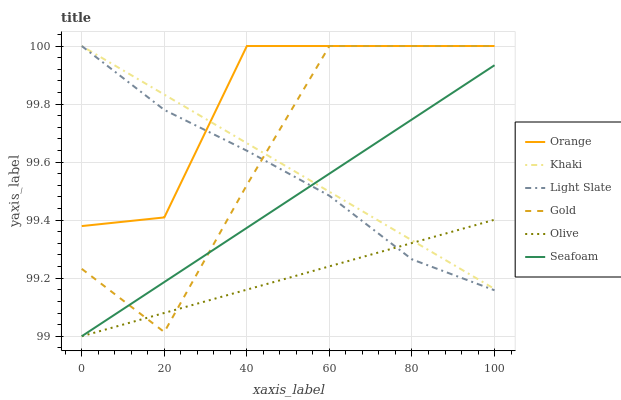Does Olive have the minimum area under the curve?
Answer yes or no. Yes. Does Orange have the maximum area under the curve?
Answer yes or no. Yes. Does Gold have the minimum area under the curve?
Answer yes or no. No. Does Gold have the maximum area under the curve?
Answer yes or no. No. Is Khaki the smoothest?
Answer yes or no. Yes. Is Gold the roughest?
Answer yes or no. Yes. Is Light Slate the smoothest?
Answer yes or no. No. Is Light Slate the roughest?
Answer yes or no. No. Does Gold have the lowest value?
Answer yes or no. No. Does Orange have the highest value?
Answer yes or no. Yes. Does Seafoam have the highest value?
Answer yes or no. No. Is Seafoam less than Orange?
Answer yes or no. Yes. Is Orange greater than Olive?
Answer yes or no. Yes. Does Orange intersect Khaki?
Answer yes or no. Yes. Is Orange less than Khaki?
Answer yes or no. No. Is Orange greater than Khaki?
Answer yes or no. No. Does Seafoam intersect Orange?
Answer yes or no. No. 